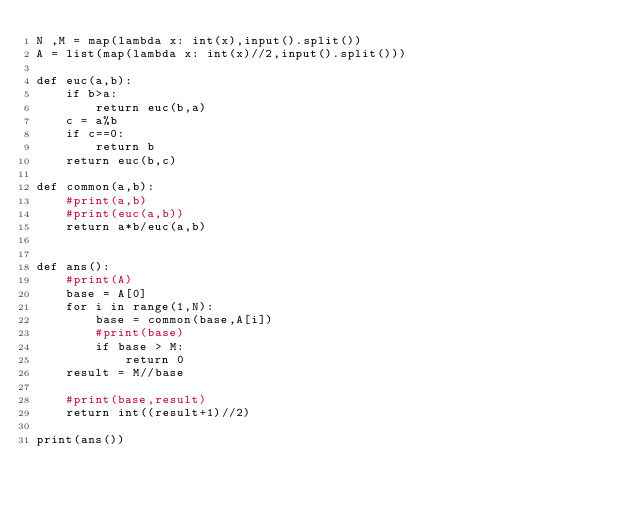<code> <loc_0><loc_0><loc_500><loc_500><_Python_>N ,M = map(lambda x: int(x),input().split())
A = list(map(lambda x: int(x)//2,input().split()))

def euc(a,b):
    if b>a:
        return euc(b,a)
    c = a%b
    if c==0:
        return b
    return euc(b,c)

def common(a,b):
    #print(a,b)
    #print(euc(a,b))
    return a*b/euc(a,b)


def ans():
    #print(A)
    base = A[0]
    for i in range(1,N):
        base = common(base,A[i])
        #print(base)
        if base > M:
            return 0
    result = M//base
    
    #print(base,result)
    return int((result+1)//2)

print(ans())


</code> 